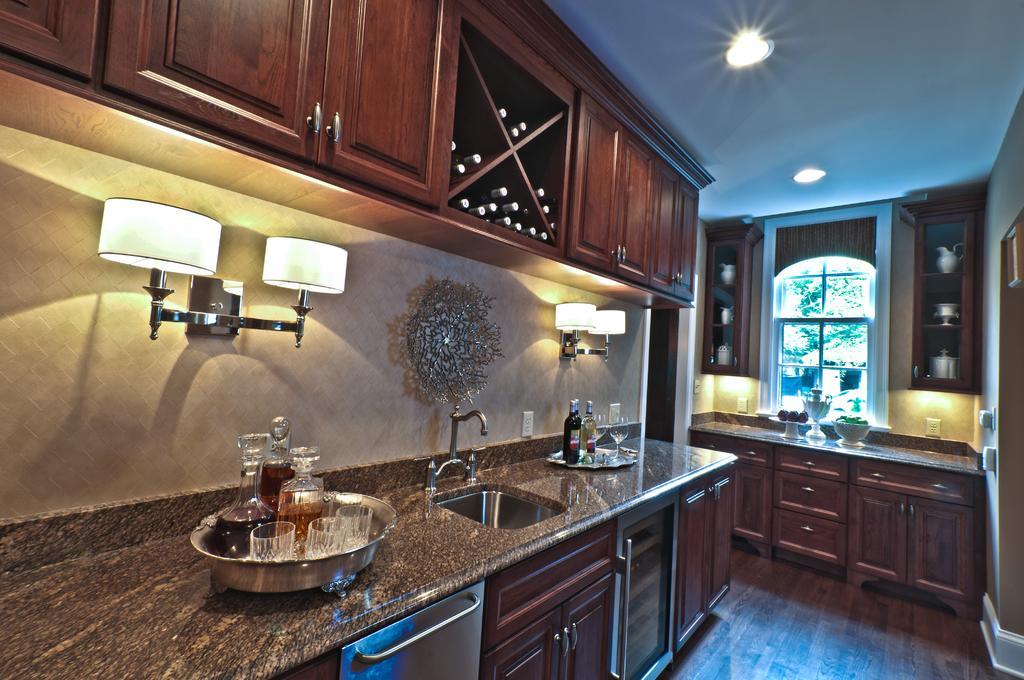How would you summarize this image in a sentence or two? This image is taken in a kitchen. On the right side we can see cupboards, windows, some objects and countertop. On the left side of the image we can see bottles, glasses, vessel, sink, cupboards, lights, switch board and wall. 